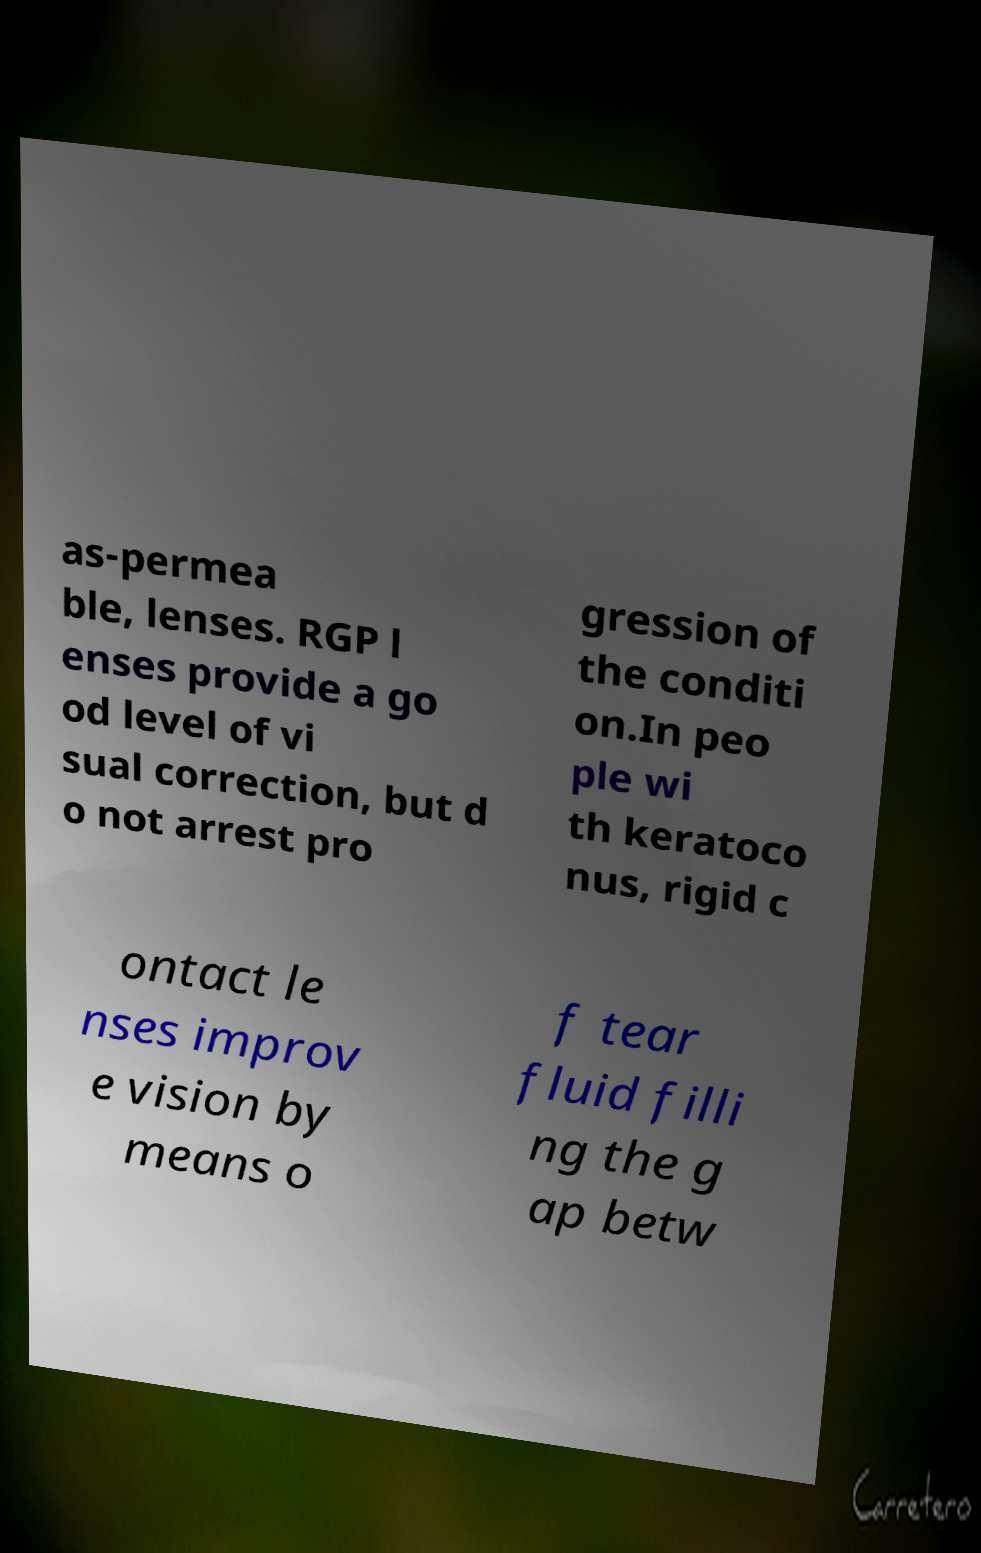I need the written content from this picture converted into text. Can you do that? as-permea ble, lenses. RGP l enses provide a go od level of vi sual correction, but d o not arrest pro gression of the conditi on.In peo ple wi th keratoco nus, rigid c ontact le nses improv e vision by means o f tear fluid filli ng the g ap betw 